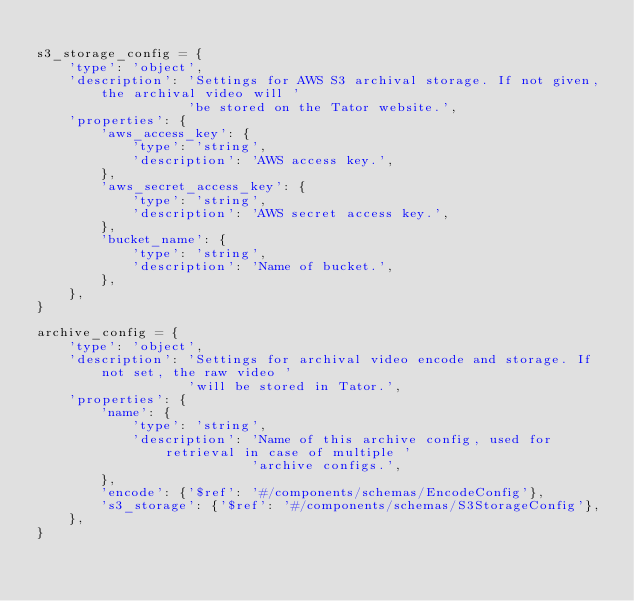Convert code to text. <code><loc_0><loc_0><loc_500><loc_500><_Python_>
s3_storage_config = {
    'type': 'object',
    'description': 'Settings for AWS S3 archival storage. If not given, the archival video will '
                   'be stored on the Tator website.',
    'properties': {
        'aws_access_key': {
            'type': 'string',
            'description': 'AWS access key.',
        },
        'aws_secret_access_key': {
            'type': 'string',
            'description': 'AWS secret access key.',
        },
        'bucket_name': {
            'type': 'string',
            'description': 'Name of bucket.',
        },
    },
}

archive_config = {
    'type': 'object',
    'description': 'Settings for archival video encode and storage. If not set, the raw video '
                   'will be stored in Tator.',
    'properties': {
        'name': {
            'type': 'string',
            'description': 'Name of this archive config, used for retrieval in case of multiple '
                           'archive configs.',
        },
        'encode': {'$ref': '#/components/schemas/EncodeConfig'},
        's3_storage': {'$ref': '#/components/schemas/S3StorageConfig'},
    },
}
</code> 